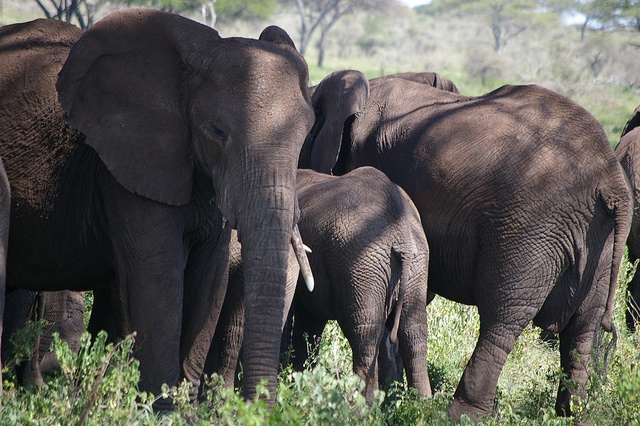Describe the objects in this image and their specific colors. I can see elephant in darkgray, black, and gray tones, elephant in darkgray, black, and gray tones, elephant in darkgray, black, and gray tones, and elephant in darkgray, black, and gray tones in this image. 